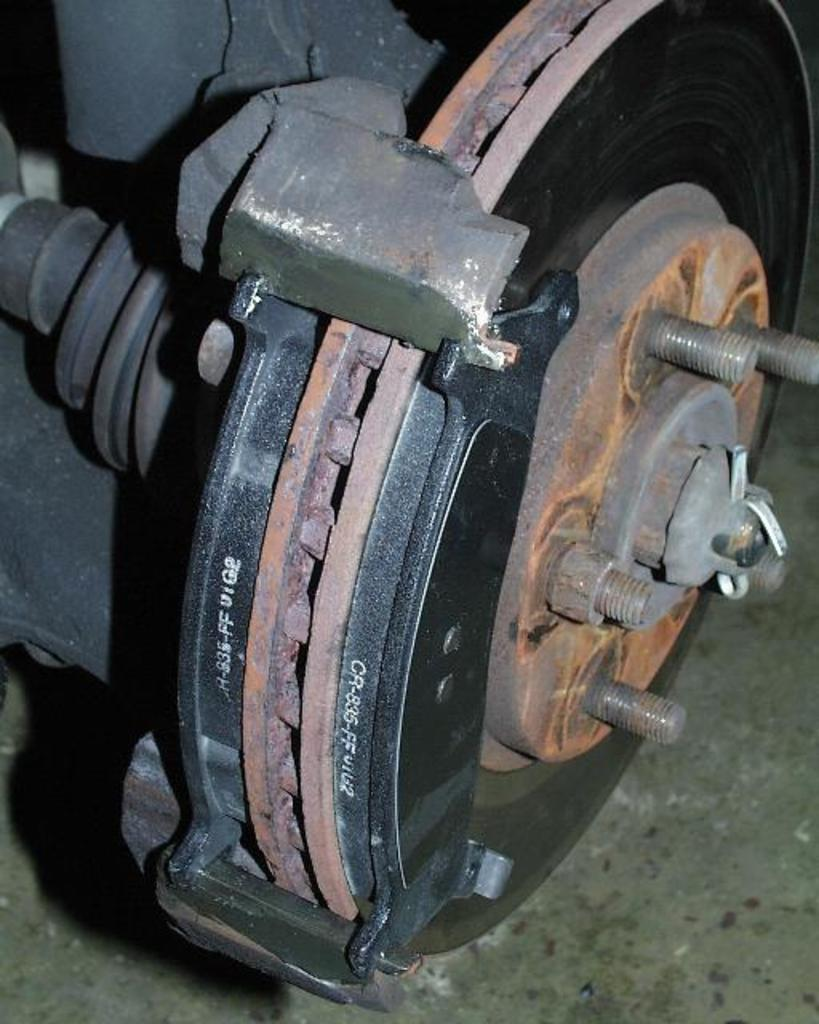What type of object can be seen in the image? There is a metal object in the image. Where is the metal object located? The metal object is placed on the floor. What does the metal object resemble? The metal object resembles a part of a vehicle. What type of teaching method is being demonstrated in the image? There is no teaching method or activity present in the image; it features a metal object resembling a part of a vehicle. How does the tramp contribute to the overall scene in the image? There is no tramp present in the image; it only contains a metal object resembling a part of a vehicle. 